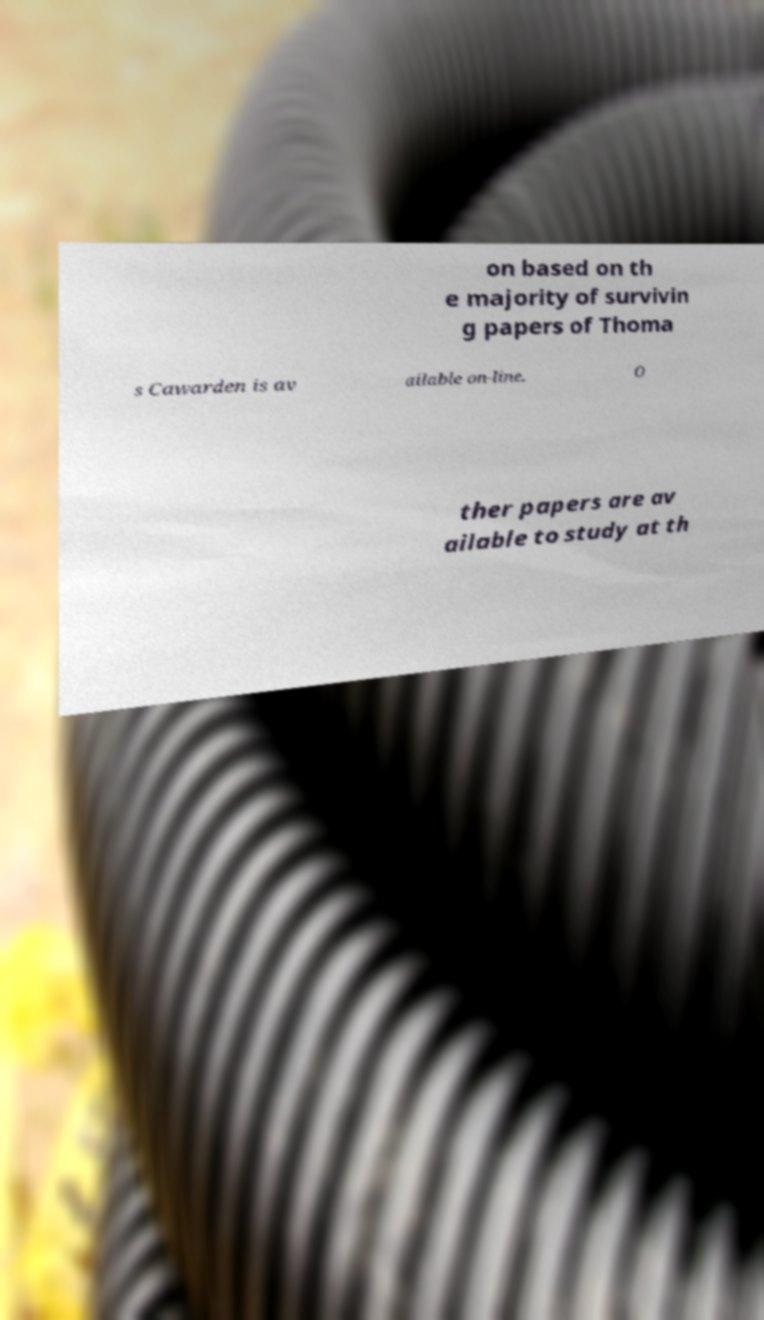Can you read and provide the text displayed in the image?This photo seems to have some interesting text. Can you extract and type it out for me? on based on th e majority of survivin g papers of Thoma s Cawarden is av ailable on-line. O ther papers are av ailable to study at th 